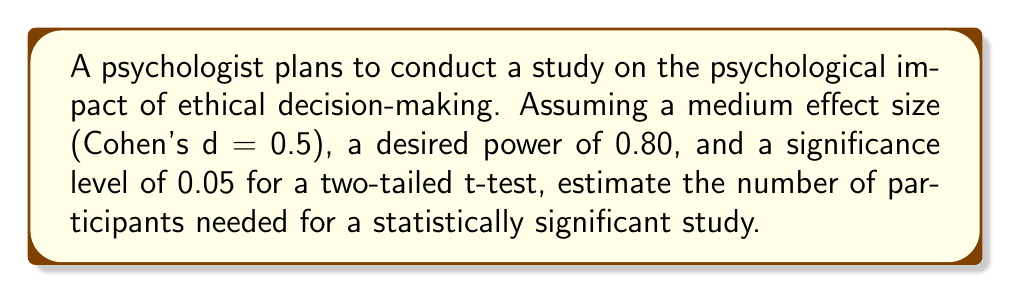Show me your answer to this math problem. To estimate the number of participants needed for a statistically significant study, we'll use the power analysis formula for a two-tailed t-test:

1) The formula for sample size (n) is:
   $$n = \frac{2(z_{1-\alpha/2} + z_{1-\beta})^2}{\delta^2}$$

   Where:
   $z_{1-\alpha/2}$ is the critical value for the significance level
   $z_{1-\beta}$ is the critical value for the desired power
   $\delta$ is the standardized effect size (Cohen's d)

2) Given:
   - Significance level ($\alpha$) = 0.05
   - Desired power (1 - $\beta$) = 0.80
   - Effect size (Cohen's d) = 0.5

3) Find the critical values:
   - For $\alpha = 0.05$, $z_{1-\alpha/2} = 1.96$
   - For power = 0.80, $z_{1-\beta} = 0.84$

4) Substitute these values into the formula:
   $$n = \frac{2(1.96 + 0.84)^2}{(0.5)^2}$$

5) Simplify:
   $$n = \frac{2(2.80)^2}{0.25} = \frac{2(7.84)}{0.25} = \frac{15.68}{0.25} = 62.72$$

6) Round up to the nearest whole number:
   $n = 63$

Therefore, the psychologist needs at least 63 participants for a statistically significant study on ethical decision-making, given the specified parameters.
Answer: 63 participants 